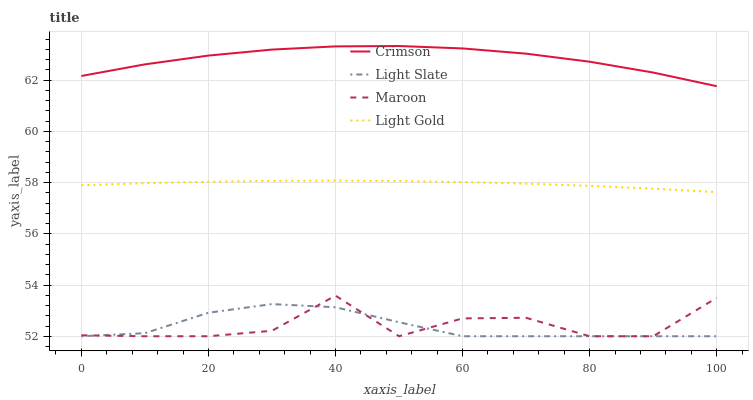Does Light Slate have the minimum area under the curve?
Answer yes or no. Yes. Does Crimson have the maximum area under the curve?
Answer yes or no. Yes. Does Light Gold have the minimum area under the curve?
Answer yes or no. No. Does Light Gold have the maximum area under the curve?
Answer yes or no. No. Is Light Gold the smoothest?
Answer yes or no. Yes. Is Maroon the roughest?
Answer yes or no. Yes. Is Light Slate the smoothest?
Answer yes or no. No. Is Light Slate the roughest?
Answer yes or no. No. Does Light Slate have the lowest value?
Answer yes or no. Yes. Does Light Gold have the lowest value?
Answer yes or no. No. Does Crimson have the highest value?
Answer yes or no. Yes. Does Light Gold have the highest value?
Answer yes or no. No. Is Light Gold less than Crimson?
Answer yes or no. Yes. Is Crimson greater than Maroon?
Answer yes or no. Yes. Does Maroon intersect Light Slate?
Answer yes or no. Yes. Is Maroon less than Light Slate?
Answer yes or no. No. Is Maroon greater than Light Slate?
Answer yes or no. No. Does Light Gold intersect Crimson?
Answer yes or no. No. 